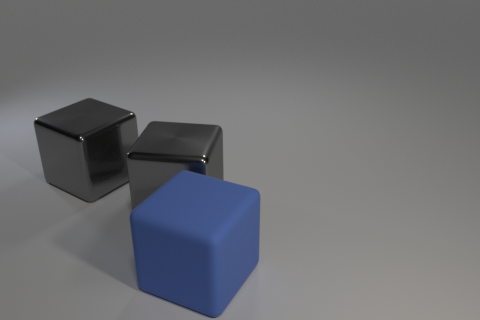Subtract all big gray metal cubes. How many cubes are left? 1 Add 1 shiny objects. How many objects exist? 4 Subtract all blue blocks. How many blocks are left? 2 Subtract all yellow cylinders. How many gray cubes are left? 2 Subtract all large matte cubes. Subtract all yellow rubber things. How many objects are left? 2 Add 3 big metallic objects. How many big metallic objects are left? 5 Add 1 big shiny things. How many big shiny things exist? 3 Subtract 0 yellow cylinders. How many objects are left? 3 Subtract 1 blocks. How many blocks are left? 2 Subtract all brown cubes. Subtract all gray cylinders. How many cubes are left? 3 